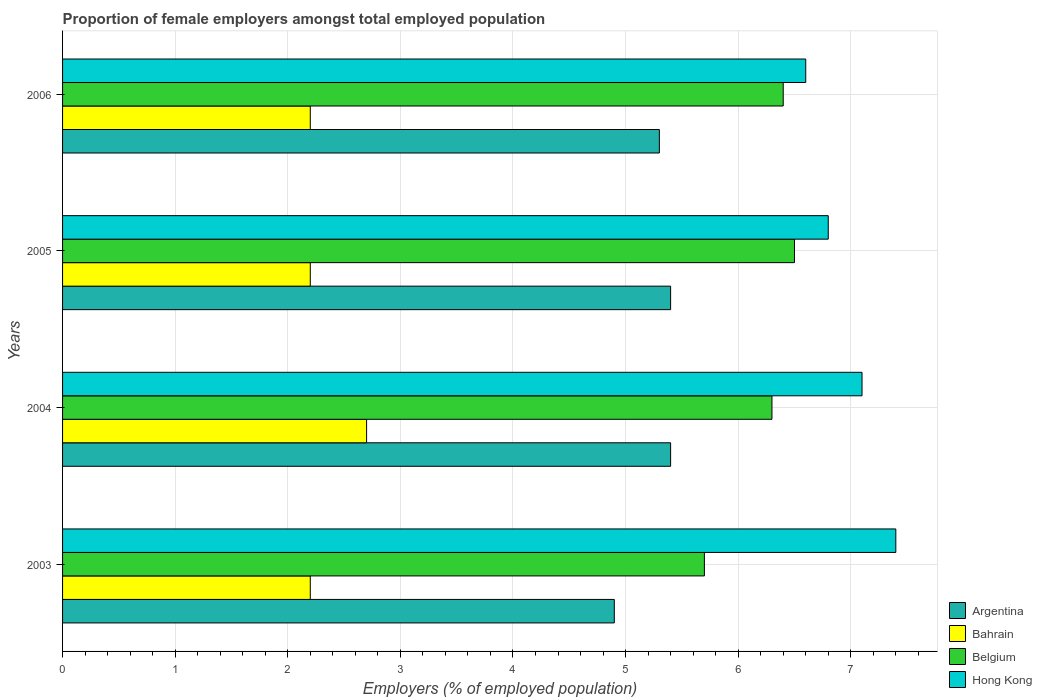Are the number of bars per tick equal to the number of legend labels?
Keep it short and to the point. Yes. How many bars are there on the 1st tick from the top?
Offer a terse response. 4. What is the label of the 1st group of bars from the top?
Provide a short and direct response. 2006. What is the proportion of female employers in Argentina in 2006?
Offer a terse response. 5.3. Across all years, what is the maximum proportion of female employers in Argentina?
Keep it short and to the point. 5.4. Across all years, what is the minimum proportion of female employers in Belgium?
Give a very brief answer. 5.7. What is the total proportion of female employers in Argentina in the graph?
Make the answer very short. 21. What is the difference between the proportion of female employers in Argentina in 2005 and the proportion of female employers in Bahrain in 2003?
Make the answer very short. 3.2. What is the average proportion of female employers in Argentina per year?
Make the answer very short. 5.25. In the year 2005, what is the difference between the proportion of female employers in Belgium and proportion of female employers in Hong Kong?
Your response must be concise. -0.3. What is the ratio of the proportion of female employers in Argentina in 2003 to that in 2004?
Your answer should be very brief. 0.91. Is the difference between the proportion of female employers in Belgium in 2003 and 2004 greater than the difference between the proportion of female employers in Hong Kong in 2003 and 2004?
Provide a short and direct response. No. What is the difference between the highest and the second highest proportion of female employers in Argentina?
Give a very brief answer. 0. Is the sum of the proportion of female employers in Belgium in 2005 and 2006 greater than the maximum proportion of female employers in Bahrain across all years?
Make the answer very short. Yes. Is it the case that in every year, the sum of the proportion of female employers in Hong Kong and proportion of female employers in Belgium is greater than the sum of proportion of female employers in Argentina and proportion of female employers in Bahrain?
Provide a short and direct response. No. How many bars are there?
Your answer should be very brief. 16. Are the values on the major ticks of X-axis written in scientific E-notation?
Your answer should be very brief. No. Does the graph contain any zero values?
Give a very brief answer. No. Does the graph contain grids?
Offer a very short reply. Yes. What is the title of the graph?
Offer a terse response. Proportion of female employers amongst total employed population. Does "Armenia" appear as one of the legend labels in the graph?
Your response must be concise. No. What is the label or title of the X-axis?
Your response must be concise. Employers (% of employed population). What is the Employers (% of employed population) in Argentina in 2003?
Your response must be concise. 4.9. What is the Employers (% of employed population) of Bahrain in 2003?
Keep it short and to the point. 2.2. What is the Employers (% of employed population) of Belgium in 2003?
Your response must be concise. 5.7. What is the Employers (% of employed population) in Hong Kong in 2003?
Offer a terse response. 7.4. What is the Employers (% of employed population) in Argentina in 2004?
Offer a very short reply. 5.4. What is the Employers (% of employed population) of Bahrain in 2004?
Offer a very short reply. 2.7. What is the Employers (% of employed population) of Belgium in 2004?
Offer a terse response. 6.3. What is the Employers (% of employed population) in Hong Kong in 2004?
Give a very brief answer. 7.1. What is the Employers (% of employed population) of Argentina in 2005?
Offer a terse response. 5.4. What is the Employers (% of employed population) of Bahrain in 2005?
Give a very brief answer. 2.2. What is the Employers (% of employed population) of Belgium in 2005?
Your response must be concise. 6.5. What is the Employers (% of employed population) of Hong Kong in 2005?
Offer a terse response. 6.8. What is the Employers (% of employed population) in Argentina in 2006?
Your answer should be very brief. 5.3. What is the Employers (% of employed population) of Bahrain in 2006?
Provide a succinct answer. 2.2. What is the Employers (% of employed population) of Belgium in 2006?
Provide a short and direct response. 6.4. What is the Employers (% of employed population) of Hong Kong in 2006?
Make the answer very short. 6.6. Across all years, what is the maximum Employers (% of employed population) in Argentina?
Offer a terse response. 5.4. Across all years, what is the maximum Employers (% of employed population) in Bahrain?
Give a very brief answer. 2.7. Across all years, what is the maximum Employers (% of employed population) of Belgium?
Provide a succinct answer. 6.5. Across all years, what is the maximum Employers (% of employed population) in Hong Kong?
Give a very brief answer. 7.4. Across all years, what is the minimum Employers (% of employed population) of Argentina?
Your answer should be compact. 4.9. Across all years, what is the minimum Employers (% of employed population) in Bahrain?
Make the answer very short. 2.2. Across all years, what is the minimum Employers (% of employed population) in Belgium?
Your response must be concise. 5.7. Across all years, what is the minimum Employers (% of employed population) of Hong Kong?
Ensure brevity in your answer.  6.6. What is the total Employers (% of employed population) of Belgium in the graph?
Offer a very short reply. 24.9. What is the total Employers (% of employed population) of Hong Kong in the graph?
Provide a short and direct response. 27.9. What is the difference between the Employers (% of employed population) in Argentina in 2003 and that in 2004?
Provide a succinct answer. -0.5. What is the difference between the Employers (% of employed population) in Belgium in 2003 and that in 2004?
Keep it short and to the point. -0.6. What is the difference between the Employers (% of employed population) in Hong Kong in 2003 and that in 2004?
Keep it short and to the point. 0.3. What is the difference between the Employers (% of employed population) of Argentina in 2003 and that in 2005?
Ensure brevity in your answer.  -0.5. What is the difference between the Employers (% of employed population) of Hong Kong in 2003 and that in 2005?
Make the answer very short. 0.6. What is the difference between the Employers (% of employed population) in Argentina in 2003 and that in 2006?
Give a very brief answer. -0.4. What is the difference between the Employers (% of employed population) of Bahrain in 2003 and that in 2006?
Keep it short and to the point. 0. What is the difference between the Employers (% of employed population) in Hong Kong in 2003 and that in 2006?
Make the answer very short. 0.8. What is the difference between the Employers (% of employed population) of Bahrain in 2004 and that in 2005?
Provide a succinct answer. 0.5. What is the difference between the Employers (% of employed population) in Belgium in 2004 and that in 2005?
Your response must be concise. -0.2. What is the difference between the Employers (% of employed population) of Argentina in 2004 and that in 2006?
Provide a short and direct response. 0.1. What is the difference between the Employers (% of employed population) of Bahrain in 2004 and that in 2006?
Provide a short and direct response. 0.5. What is the difference between the Employers (% of employed population) in Belgium in 2004 and that in 2006?
Ensure brevity in your answer.  -0.1. What is the difference between the Employers (% of employed population) of Hong Kong in 2004 and that in 2006?
Give a very brief answer. 0.5. What is the difference between the Employers (% of employed population) of Argentina in 2005 and that in 2006?
Your answer should be compact. 0.1. What is the difference between the Employers (% of employed population) in Bahrain in 2005 and that in 2006?
Your answer should be very brief. 0. What is the difference between the Employers (% of employed population) in Belgium in 2005 and that in 2006?
Offer a terse response. 0.1. What is the difference between the Employers (% of employed population) in Hong Kong in 2005 and that in 2006?
Provide a succinct answer. 0.2. What is the difference between the Employers (% of employed population) of Argentina in 2003 and the Employers (% of employed population) of Belgium in 2004?
Make the answer very short. -1.4. What is the difference between the Employers (% of employed population) of Argentina in 2003 and the Employers (% of employed population) of Hong Kong in 2004?
Give a very brief answer. -2.2. What is the difference between the Employers (% of employed population) in Bahrain in 2003 and the Employers (% of employed population) in Belgium in 2004?
Your answer should be compact. -4.1. What is the difference between the Employers (% of employed population) in Bahrain in 2003 and the Employers (% of employed population) in Hong Kong in 2004?
Keep it short and to the point. -4.9. What is the difference between the Employers (% of employed population) in Argentina in 2003 and the Employers (% of employed population) in Hong Kong in 2005?
Provide a short and direct response. -1.9. What is the difference between the Employers (% of employed population) in Bahrain in 2003 and the Employers (% of employed population) in Hong Kong in 2005?
Make the answer very short. -4.6. What is the difference between the Employers (% of employed population) of Belgium in 2003 and the Employers (% of employed population) of Hong Kong in 2005?
Your answer should be very brief. -1.1. What is the difference between the Employers (% of employed population) in Argentina in 2003 and the Employers (% of employed population) in Belgium in 2006?
Keep it short and to the point. -1.5. What is the difference between the Employers (% of employed population) in Bahrain in 2003 and the Employers (% of employed population) in Belgium in 2006?
Keep it short and to the point. -4.2. What is the difference between the Employers (% of employed population) in Belgium in 2003 and the Employers (% of employed population) in Hong Kong in 2006?
Offer a very short reply. -0.9. What is the difference between the Employers (% of employed population) of Argentina in 2004 and the Employers (% of employed population) of Bahrain in 2005?
Your answer should be very brief. 3.2. What is the difference between the Employers (% of employed population) of Argentina in 2004 and the Employers (% of employed population) of Hong Kong in 2005?
Offer a terse response. -1.4. What is the difference between the Employers (% of employed population) in Bahrain in 2004 and the Employers (% of employed population) in Hong Kong in 2005?
Your response must be concise. -4.1. What is the difference between the Employers (% of employed population) in Belgium in 2004 and the Employers (% of employed population) in Hong Kong in 2005?
Provide a succinct answer. -0.5. What is the difference between the Employers (% of employed population) in Argentina in 2004 and the Employers (% of employed population) in Bahrain in 2006?
Your answer should be compact. 3.2. What is the difference between the Employers (% of employed population) in Bahrain in 2004 and the Employers (% of employed population) in Hong Kong in 2006?
Keep it short and to the point. -3.9. What is the difference between the Employers (% of employed population) in Argentina in 2005 and the Employers (% of employed population) in Bahrain in 2006?
Provide a short and direct response. 3.2. What is the difference between the Employers (% of employed population) in Argentina in 2005 and the Employers (% of employed population) in Belgium in 2006?
Your answer should be very brief. -1. What is the difference between the Employers (% of employed population) in Bahrain in 2005 and the Employers (% of employed population) in Belgium in 2006?
Provide a succinct answer. -4.2. What is the average Employers (% of employed population) in Argentina per year?
Give a very brief answer. 5.25. What is the average Employers (% of employed population) in Bahrain per year?
Offer a terse response. 2.33. What is the average Employers (% of employed population) in Belgium per year?
Your answer should be compact. 6.22. What is the average Employers (% of employed population) of Hong Kong per year?
Your response must be concise. 6.97. In the year 2003, what is the difference between the Employers (% of employed population) in Argentina and Employers (% of employed population) in Bahrain?
Give a very brief answer. 2.7. In the year 2003, what is the difference between the Employers (% of employed population) in Argentina and Employers (% of employed population) in Belgium?
Offer a terse response. -0.8. In the year 2003, what is the difference between the Employers (% of employed population) in Bahrain and Employers (% of employed population) in Hong Kong?
Your answer should be compact. -5.2. In the year 2004, what is the difference between the Employers (% of employed population) in Argentina and Employers (% of employed population) in Bahrain?
Make the answer very short. 2.7. In the year 2004, what is the difference between the Employers (% of employed population) of Bahrain and Employers (% of employed population) of Hong Kong?
Offer a terse response. -4.4. In the year 2005, what is the difference between the Employers (% of employed population) of Argentina and Employers (% of employed population) of Bahrain?
Give a very brief answer. 3.2. In the year 2005, what is the difference between the Employers (% of employed population) in Argentina and Employers (% of employed population) in Belgium?
Keep it short and to the point. -1.1. In the year 2005, what is the difference between the Employers (% of employed population) of Bahrain and Employers (% of employed population) of Hong Kong?
Provide a short and direct response. -4.6. In the year 2005, what is the difference between the Employers (% of employed population) in Belgium and Employers (% of employed population) in Hong Kong?
Your answer should be compact. -0.3. In the year 2006, what is the difference between the Employers (% of employed population) in Argentina and Employers (% of employed population) in Bahrain?
Provide a succinct answer. 3.1. In the year 2006, what is the difference between the Employers (% of employed population) in Argentina and Employers (% of employed population) in Belgium?
Offer a terse response. -1.1. In the year 2006, what is the difference between the Employers (% of employed population) in Argentina and Employers (% of employed population) in Hong Kong?
Your answer should be compact. -1.3. In the year 2006, what is the difference between the Employers (% of employed population) of Bahrain and Employers (% of employed population) of Belgium?
Offer a terse response. -4.2. In the year 2006, what is the difference between the Employers (% of employed population) of Bahrain and Employers (% of employed population) of Hong Kong?
Your answer should be compact. -4.4. In the year 2006, what is the difference between the Employers (% of employed population) in Belgium and Employers (% of employed population) in Hong Kong?
Give a very brief answer. -0.2. What is the ratio of the Employers (% of employed population) of Argentina in 2003 to that in 2004?
Keep it short and to the point. 0.91. What is the ratio of the Employers (% of employed population) of Bahrain in 2003 to that in 2004?
Your answer should be compact. 0.81. What is the ratio of the Employers (% of employed population) of Belgium in 2003 to that in 2004?
Your answer should be very brief. 0.9. What is the ratio of the Employers (% of employed population) of Hong Kong in 2003 to that in 2004?
Ensure brevity in your answer.  1.04. What is the ratio of the Employers (% of employed population) in Argentina in 2003 to that in 2005?
Your answer should be compact. 0.91. What is the ratio of the Employers (% of employed population) in Belgium in 2003 to that in 2005?
Ensure brevity in your answer.  0.88. What is the ratio of the Employers (% of employed population) of Hong Kong in 2003 to that in 2005?
Provide a short and direct response. 1.09. What is the ratio of the Employers (% of employed population) in Argentina in 2003 to that in 2006?
Keep it short and to the point. 0.92. What is the ratio of the Employers (% of employed population) in Bahrain in 2003 to that in 2006?
Keep it short and to the point. 1. What is the ratio of the Employers (% of employed population) of Belgium in 2003 to that in 2006?
Provide a succinct answer. 0.89. What is the ratio of the Employers (% of employed population) of Hong Kong in 2003 to that in 2006?
Your answer should be very brief. 1.12. What is the ratio of the Employers (% of employed population) of Argentina in 2004 to that in 2005?
Your answer should be very brief. 1. What is the ratio of the Employers (% of employed population) of Bahrain in 2004 to that in 2005?
Your response must be concise. 1.23. What is the ratio of the Employers (% of employed population) in Belgium in 2004 to that in 2005?
Make the answer very short. 0.97. What is the ratio of the Employers (% of employed population) of Hong Kong in 2004 to that in 2005?
Make the answer very short. 1.04. What is the ratio of the Employers (% of employed population) of Argentina in 2004 to that in 2006?
Provide a succinct answer. 1.02. What is the ratio of the Employers (% of employed population) in Bahrain in 2004 to that in 2006?
Ensure brevity in your answer.  1.23. What is the ratio of the Employers (% of employed population) of Belgium in 2004 to that in 2006?
Your response must be concise. 0.98. What is the ratio of the Employers (% of employed population) of Hong Kong in 2004 to that in 2006?
Your answer should be very brief. 1.08. What is the ratio of the Employers (% of employed population) in Argentina in 2005 to that in 2006?
Give a very brief answer. 1.02. What is the ratio of the Employers (% of employed population) in Belgium in 2005 to that in 2006?
Your response must be concise. 1.02. What is the ratio of the Employers (% of employed population) of Hong Kong in 2005 to that in 2006?
Your answer should be compact. 1.03. What is the difference between the highest and the second highest Employers (% of employed population) of Bahrain?
Offer a very short reply. 0.5. What is the difference between the highest and the second highest Employers (% of employed population) of Hong Kong?
Ensure brevity in your answer.  0.3. What is the difference between the highest and the lowest Employers (% of employed population) of Hong Kong?
Give a very brief answer. 0.8. 